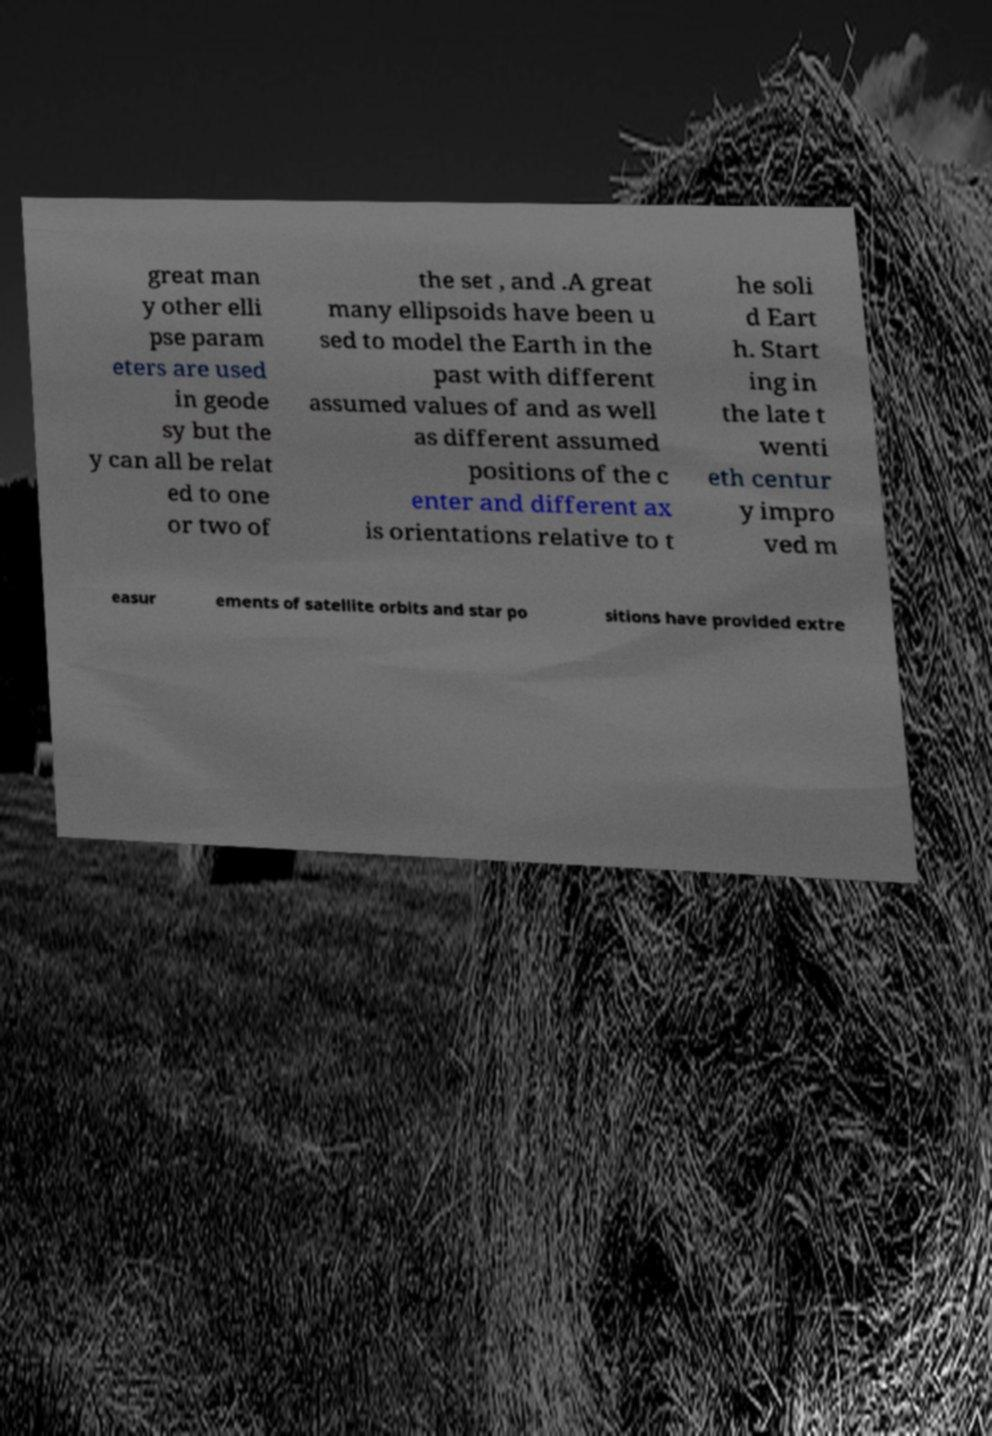What messages or text are displayed in this image? I need them in a readable, typed format. great man y other elli pse param eters are used in geode sy but the y can all be relat ed to one or two of the set , and .A great many ellipsoids have been u sed to model the Earth in the past with different assumed values of and as well as different assumed positions of the c enter and different ax is orientations relative to t he soli d Eart h. Start ing in the late t wenti eth centur y impro ved m easur ements of satellite orbits and star po sitions have provided extre 